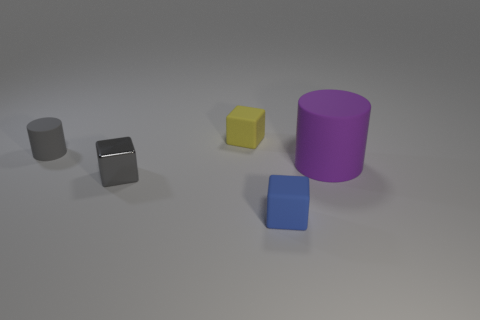Subtract all small matte blocks. How many blocks are left? 1 Subtract all purple cylinders. How many cylinders are left? 1 Subtract 2 blocks. How many blocks are left? 1 Subtract all blocks. How many objects are left? 2 Add 2 purple cylinders. How many objects exist? 7 Subtract 0 cyan balls. How many objects are left? 5 Subtract all cyan cubes. Subtract all yellow spheres. How many cubes are left? 3 Subtract all yellow spheres. How many purple cylinders are left? 1 Subtract all cubes. Subtract all cyan matte objects. How many objects are left? 2 Add 5 gray matte things. How many gray matte things are left? 6 